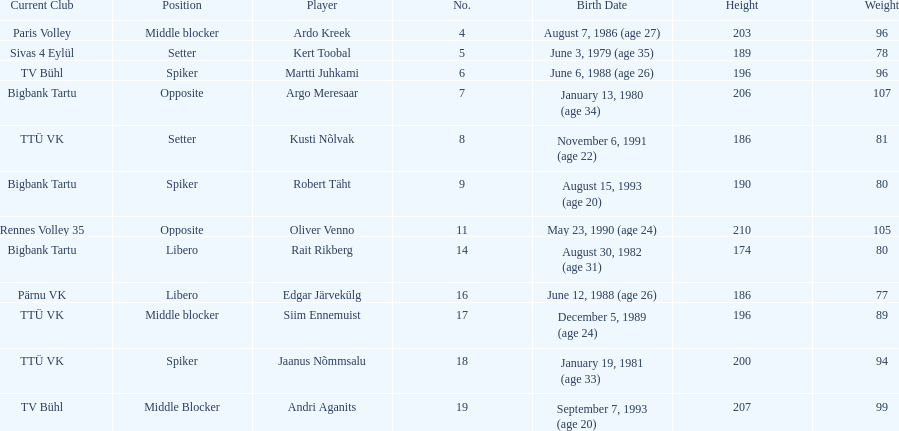How many players are middle blockers? 3. 